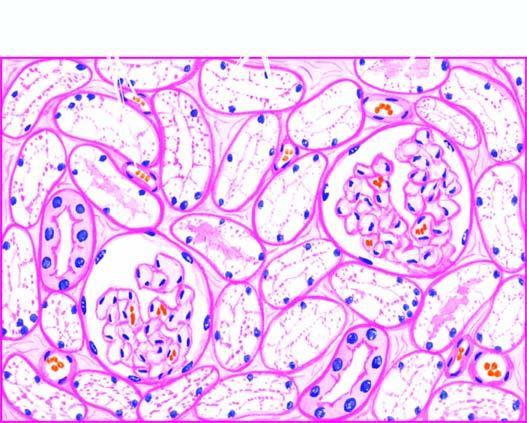re equence of events in the pathogenesis of reversible and irreversible cell injury pale?
Answer the question using a single word or phrase. No 